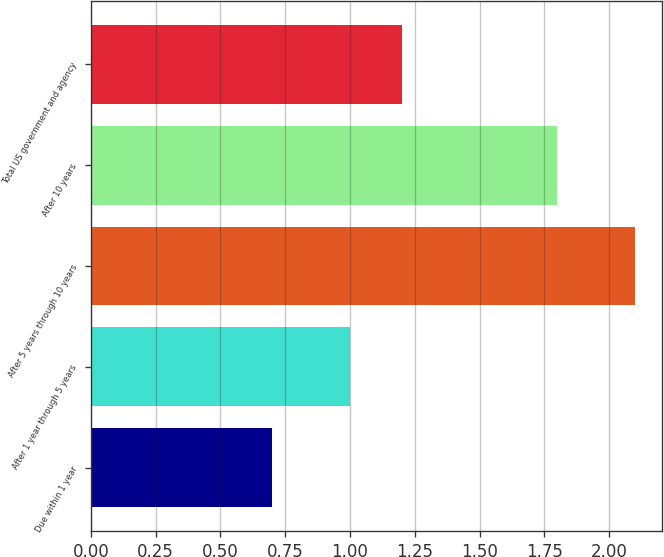Convert chart. <chart><loc_0><loc_0><loc_500><loc_500><bar_chart><fcel>Due within 1 year<fcel>After 1 year through 5 years<fcel>After 5 years through 10 years<fcel>After 10 years<fcel>Total US government and agency<nl><fcel>0.7<fcel>1<fcel>2.1<fcel>1.8<fcel>1.2<nl></chart> 